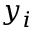<formula> <loc_0><loc_0><loc_500><loc_500>y _ { i }</formula> 